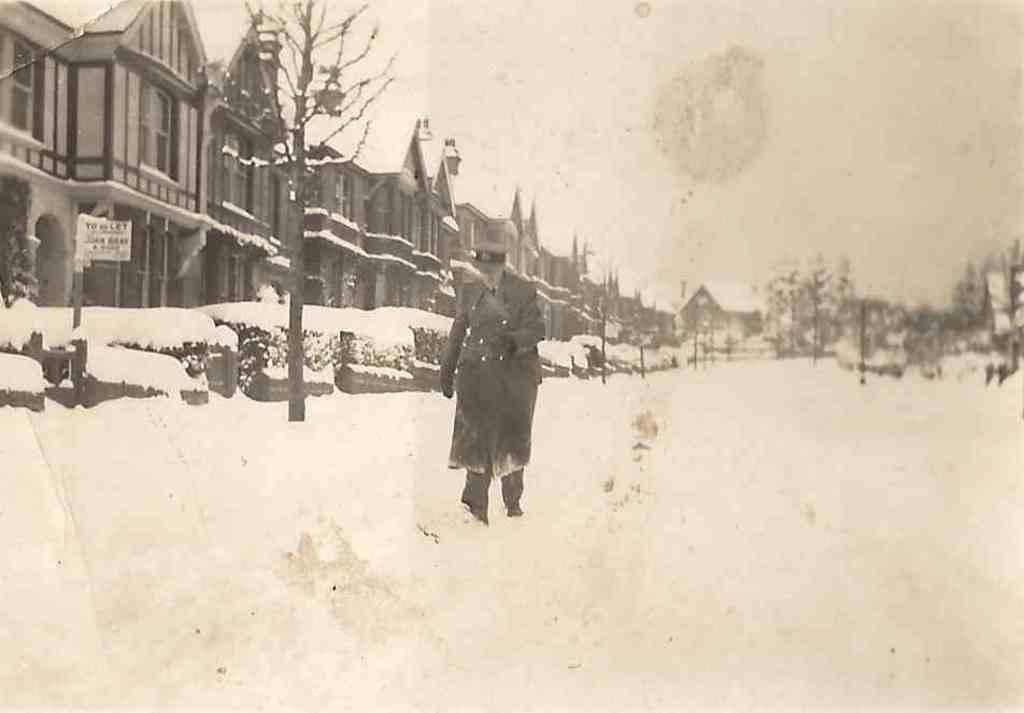What is the man in the image doing? There is a man walking in the image. What can be seen in the background of the image? There are trees and buildings in the background of the image. What is the weather like in the image? There is snow visible in the image, indicating a cold or wintry weather. What type of seed is the man planting in the image? There is no seed or planting activity present in the image; the man is simply walking. 